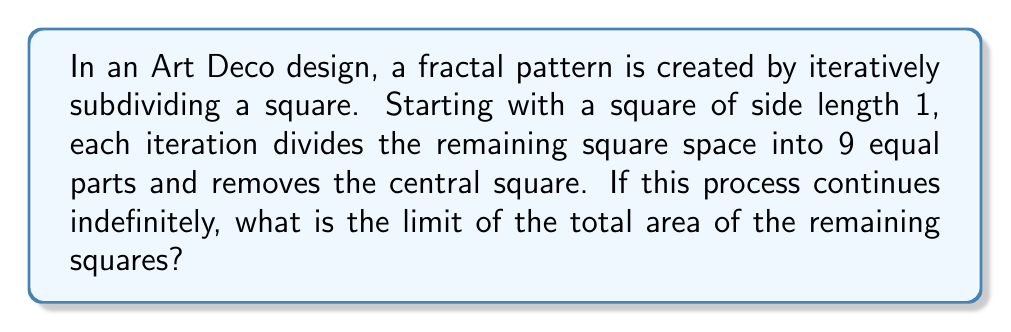Can you solve this math problem? Let's approach this step-by-step:

1) First, let's consider the area removed in each iteration:

   Iteration 0: Initial square, area = 1
   Iteration 1: Remove $\frac{1}{9}$ of the remaining area
   Iteration 2: Remove $\frac{1}{9}$ of $\frac{8}{9}$ of the original area
   Iteration 3: Remove $\frac{1}{9}$ of $(\frac{8}{9})^2$ of the original area

2) We can express this as a series. The total area removed after n iterations is:

   $$S_n = \frac{1}{9} + \frac{1}{9} \cdot \frac{8}{9} + \frac{1}{9} \cdot (\frac{8}{9})^2 + ... + \frac{1}{9} \cdot (\frac{8}{9})^{n-1}$$

3) This is a geometric series with first term $a = \frac{1}{9}$ and common ratio $r = \frac{8}{9}$

4) The sum of an infinite geometric series with $|r| < 1$ is given by $\frac{a}{1-r}$

5) In this case:

   $$\lim_{n \to \infty} S_n = \frac{\frac{1}{9}}{1-\frac{8}{9}} = \frac{\frac{1}{9}}{\frac{1}{9}} = 1$$

6) This means that as the iterations approach infinity, the total area removed approaches 1, which is the entire area of the original square.

7) Therefore, the remaining area approaches 0 as the number of iterations approaches infinity.

This fractal pattern, reminiscent of the Sierpinski carpet, creates an intricate design that could be seen in Art Deco motifs, reflecting the era's fascination with geometric patterns and modernity.
Answer: The limit of the total area of the remaining squares as the number of iterations approaches infinity is 0. 